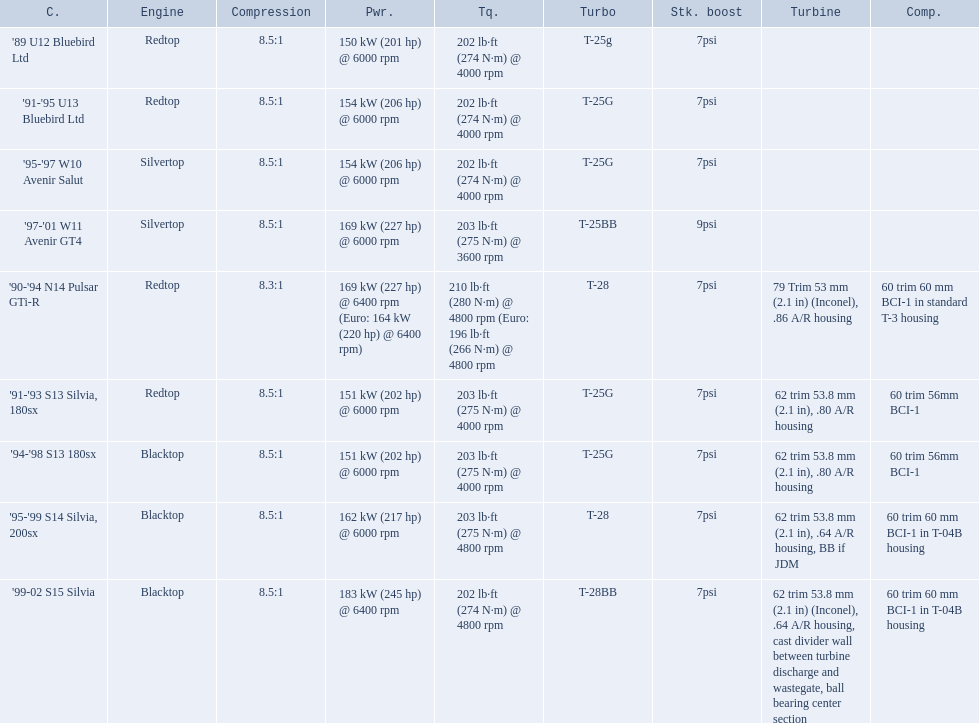What are the psi's? 7psi, 7psi, 7psi, 9psi, 7psi, 7psi, 7psi, 7psi, 7psi. What are the number(s) greater than 7? 9psi. Which car has that number? '97-'01 W11 Avenir GT4. 